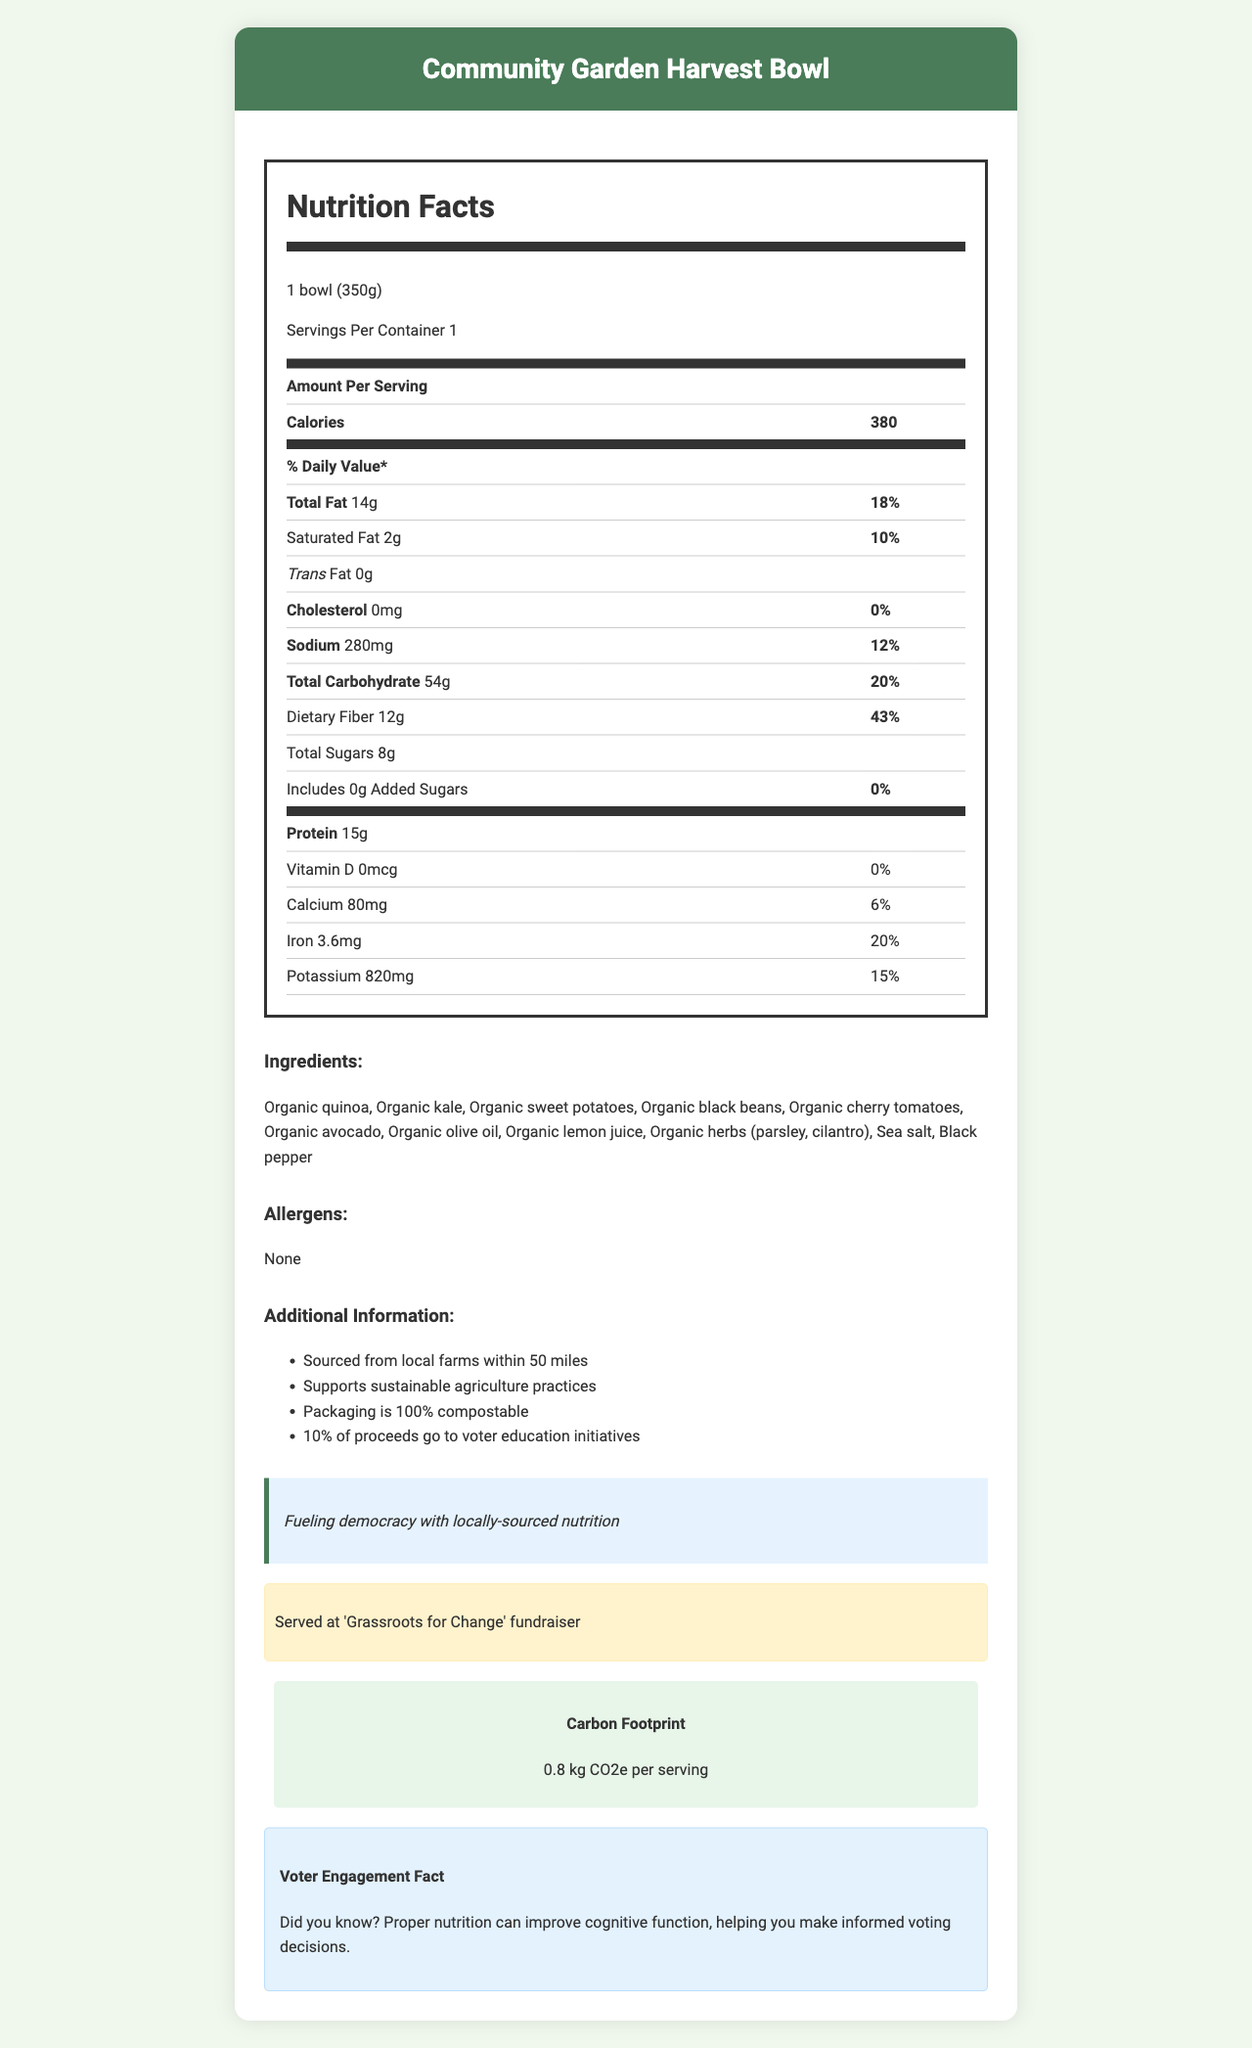what is the serving size of the Community Garden Harvest Bowl? The serving size is listed as "1 bowl (350g)" in the document.
Answer: 1 bowl (350g) how many grams of total fat are in one serving? The total fat amount is given as 14 grams.
Answer: 14g what percentage of the daily value of dietary fiber is in one serving? The daily value percentage for dietary fiber is listed as 43%.
Answer: 43% what is the amount of sodium in one serving? The sodium amount is 280 mg as specified in the document.
Answer: 280 mg how much protein does one serving provide? One serving provides 15 grams of protein.
Answer: 15g what is the political message associated with the Community Garden Harvest Bowl? The political message is explicitly mentioned as "Fueling democracy with locally-sourced nutrition."
Answer: Fueling democracy with locally-sourced nutrition from where are the ingredients for the Community Garden Harvest Bowl sourced? A. National Farms B. Local Farms C. Imported The document mentions that the ingredients are sourced from local farms within 50 miles.
Answer: B which of the following vitamins and minerals has the highest daily value percentage in one serving? I. Calcium II. Iron III. Potassium Iron has the highest daily value percentage at 20%, followed by Potassium (15%) and Calcium (6%).
Answer: II is there any cholesterol in one serving of the Community Garden Harvest Bowl? (Yes/No) The document states that the cholesterol amount is 0 mg.
Answer: No summarize the main idea of the document. The document highlights the nutrition content of the meal along with additional information supporting local sourcing, sustainability, political messages, and voter engagement.
Answer: The document provides detailed nutrition facts and additional information for the Community Garden Harvest Bowl, a locally-sourced organic meal served at political fundraisers. It includes details about serving size, calories, various nutrients, ingredients, and aligns with sustainability and voter engagement initiatives. what are the specific farms from which the ingredients are sourced? The document mentions that ingredients are sourced from local farms within 50 miles, but it does not specify the names of the farms.
Answer: Not enough information 